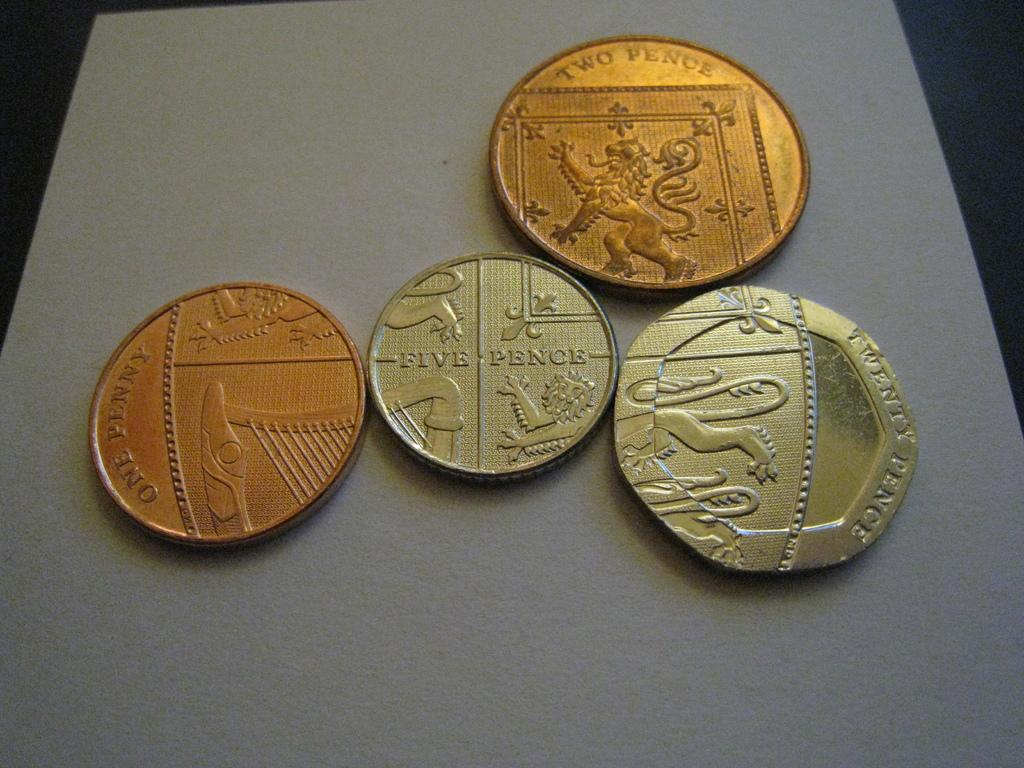Provide a one-sentence caption for the provided image. Four coins, one a five pence, one a one penny, one two pence and a twenty pence coin touch each other. 